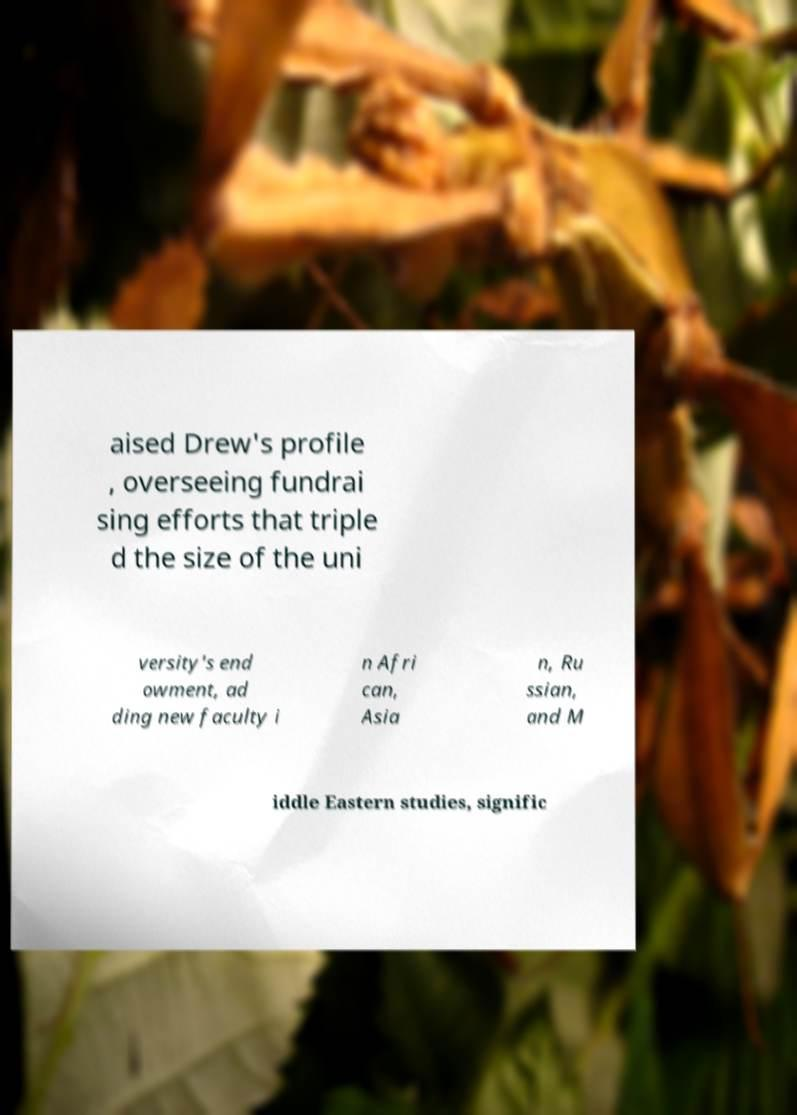What messages or text are displayed in this image? I need them in a readable, typed format. aised Drew's profile , overseeing fundrai sing efforts that triple d the size of the uni versity's end owment, ad ding new faculty i n Afri can, Asia n, Ru ssian, and M iddle Eastern studies, signific 